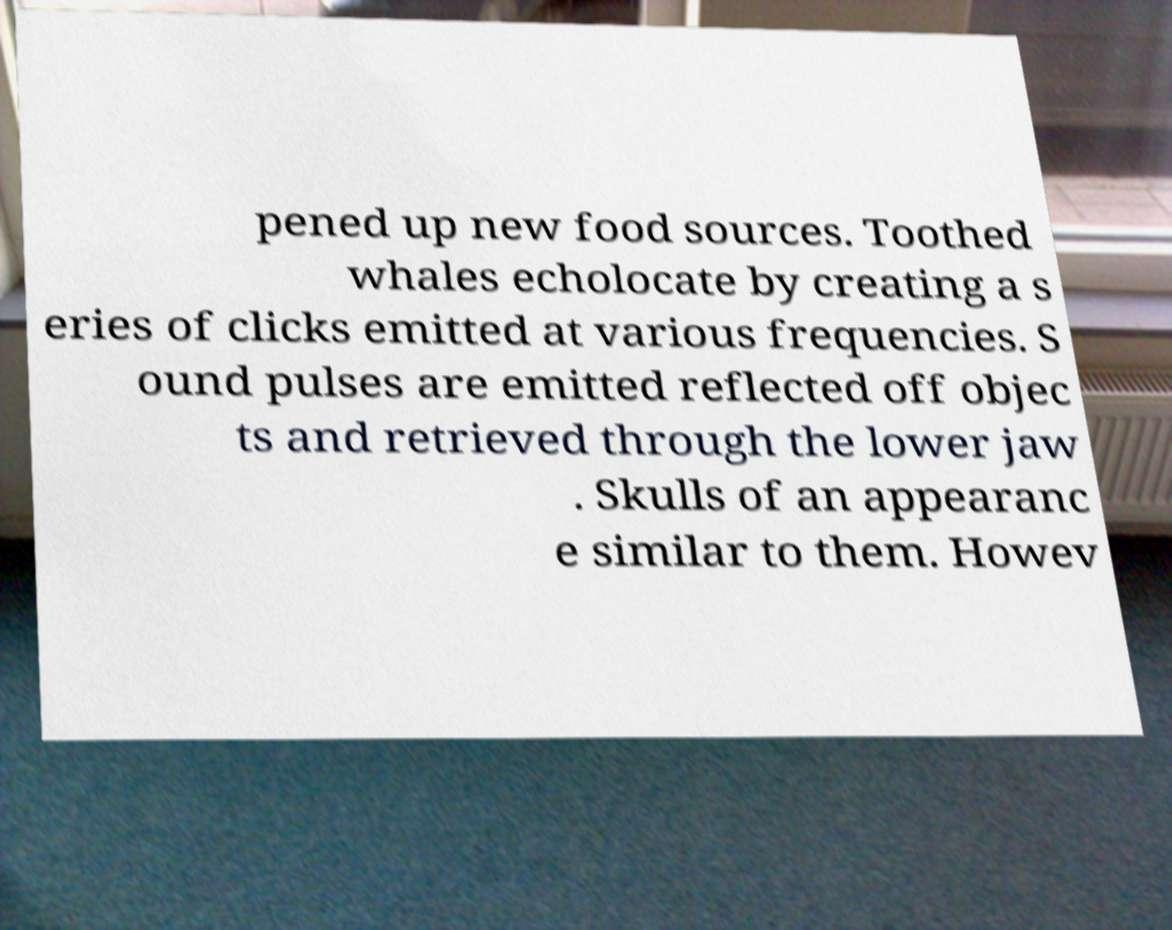There's text embedded in this image that I need extracted. Can you transcribe it verbatim? pened up new food sources. Toothed whales echolocate by creating a s eries of clicks emitted at various frequencies. S ound pulses are emitted reflected off objec ts and retrieved through the lower jaw . Skulls of an appearanc e similar to them. Howev 